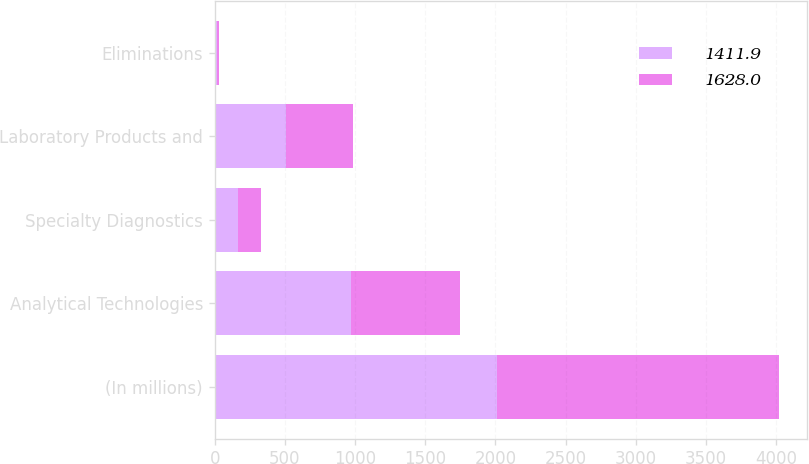Convert chart. <chart><loc_0><loc_0><loc_500><loc_500><stacked_bar_chart><ecel><fcel>(In millions)<fcel>Analytical Technologies<fcel>Specialty Diagnostics<fcel>Laboratory Products and<fcel>Eliminations<nl><fcel>1411.9<fcel>2011<fcel>972<fcel>166.7<fcel>506.8<fcel>17.5<nl><fcel>1628<fcel>2010<fcel>778.8<fcel>165.8<fcel>478<fcel>10.7<nl></chart> 